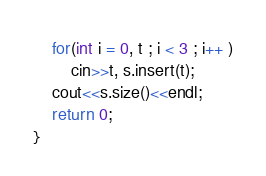Convert code to text. <code><loc_0><loc_0><loc_500><loc_500><_C++_>
    for(int i = 0, t ; i < 3 ; i++ )
        cin>>t, s.insert(t);
    cout<<s.size()<<endl;
    return 0;
}
</code> 